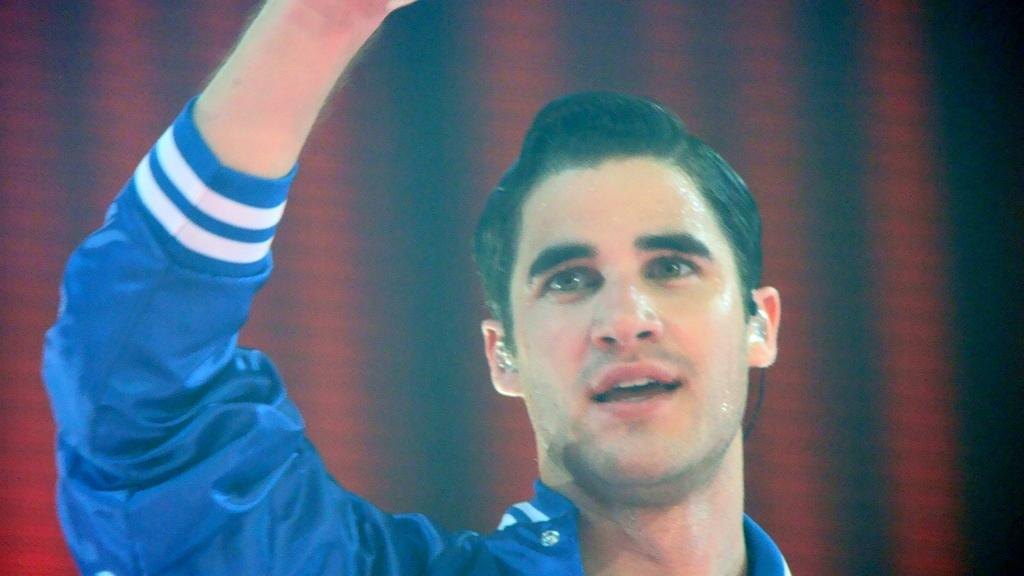What is the main subject of the image? There is a person in the image. Can you describe the person's attire? The person is wearing a blue and white color dress. What colors are used in the background of the image? The background of the image is in red and black color. What time is the van parked in front of the person in the image? There is no van present in the image. Is the crook trying to steal the person's dress in the image? There is no crook or any indication of theft in the image. 